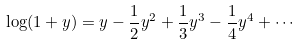<formula> <loc_0><loc_0><loc_500><loc_500>\log ( 1 + y ) = y - { \frac { 1 } { 2 } } y ^ { 2 } + { \frac { 1 } { 3 } } y ^ { 3 } - { \frac { 1 } { 4 } } y ^ { 4 } + \cdots</formula> 